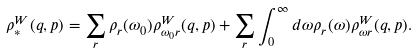Convert formula to latex. <formula><loc_0><loc_0><loc_500><loc_500>\rho _ { * } ^ { W } ( q , p ) = \sum _ { r } \rho _ { r } ( \omega _ { 0 } ) \rho _ { \omega _ { 0 } r } ^ { W } ( q , p ) + \sum _ { r } \int _ { 0 } ^ { \infty } d \omega \rho _ { r } ( \omega ) \rho _ { \omega r } ^ { W } ( q , p ) .</formula> 